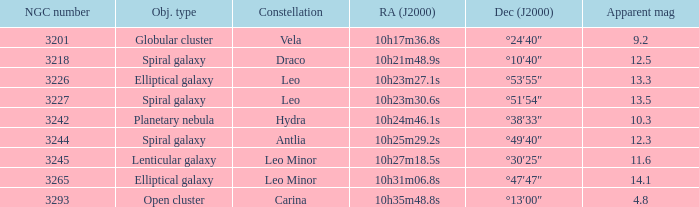What is the sum of NGC numbers for Constellation vela? 3201.0. 